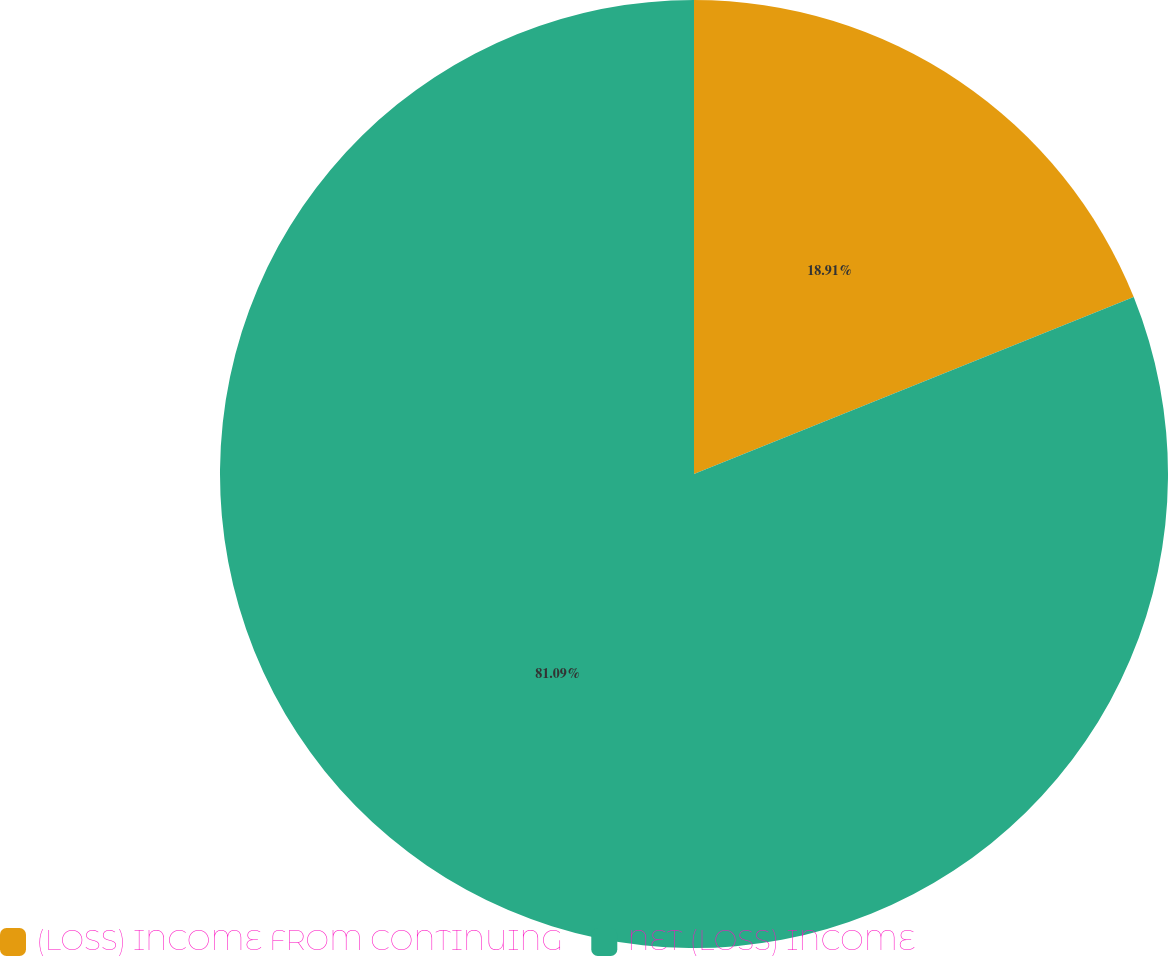Convert chart to OTSL. <chart><loc_0><loc_0><loc_500><loc_500><pie_chart><fcel>(LOSS) INCOME FROM CONTINUING<fcel>NET (LOSS) INCOME<nl><fcel>18.91%<fcel>81.09%<nl></chart> 